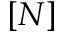Convert formula to latex. <formula><loc_0><loc_0><loc_500><loc_500>[ N ]</formula> 